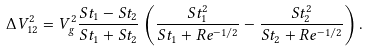Convert formula to latex. <formula><loc_0><loc_0><loc_500><loc_500>\Delta V _ { 1 2 } ^ { 2 } = V _ { g } ^ { 2 } \frac { S t _ { 1 } - S t _ { 2 } } { S t _ { 1 } + S t _ { 2 } } \left ( \frac { S t _ { 1 } ^ { 2 } } { S t _ { 1 } + R e ^ { - 1 / 2 } } - \frac { S t _ { 2 } ^ { 2 } } { S t _ { 2 } + R e ^ { - 1 / 2 } } \right ) .</formula> 